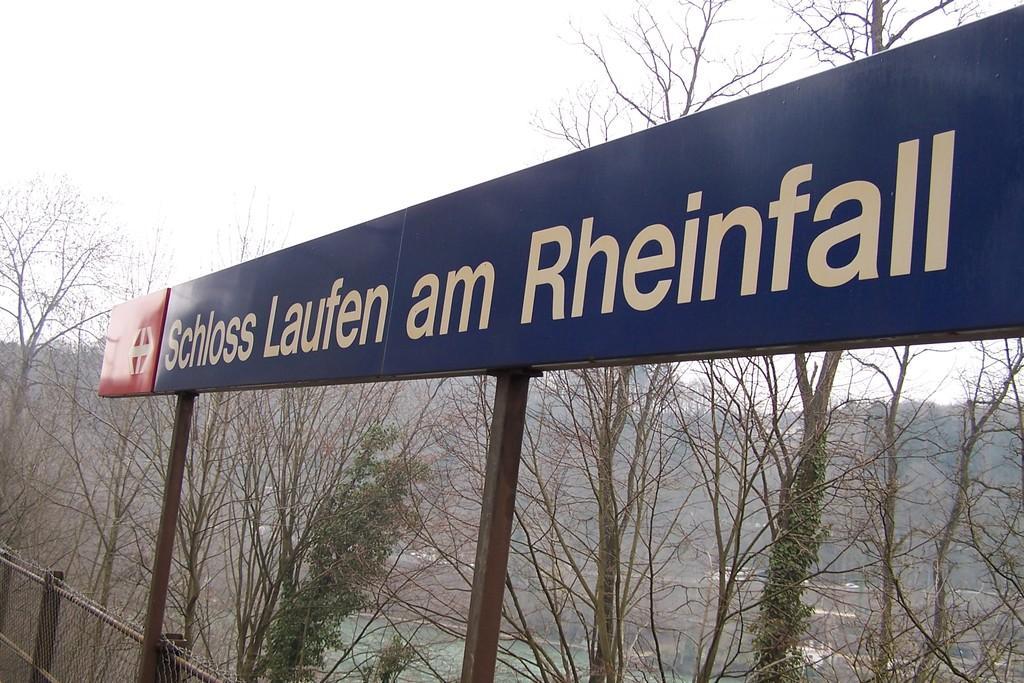In one or two sentences, can you explain what this image depicts? In this picture we can see a board in the front, there is some text on the board, in the background there are some trees and water, we can see the sky at the top of the picture. 